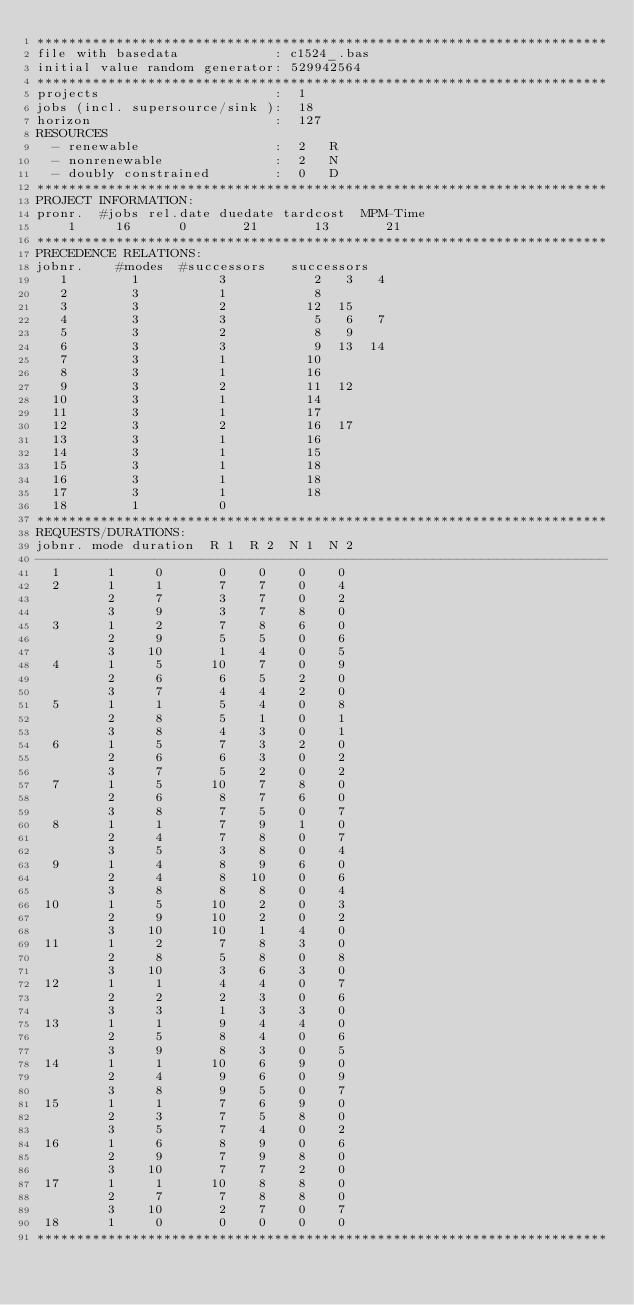<code> <loc_0><loc_0><loc_500><loc_500><_ObjectiveC_>************************************************************************
file with basedata            : c1524_.bas
initial value random generator: 529942564
************************************************************************
projects                      :  1
jobs (incl. supersource/sink ):  18
horizon                       :  127
RESOURCES
  - renewable                 :  2   R
  - nonrenewable              :  2   N
  - doubly constrained        :  0   D
************************************************************************
PROJECT INFORMATION:
pronr.  #jobs rel.date duedate tardcost  MPM-Time
    1     16      0       21       13       21
************************************************************************
PRECEDENCE RELATIONS:
jobnr.    #modes  #successors   successors
   1        1          3           2   3   4
   2        3          1           8
   3        3          2          12  15
   4        3          3           5   6   7
   5        3          2           8   9
   6        3          3           9  13  14
   7        3          1          10
   8        3          1          16
   9        3          2          11  12
  10        3          1          14
  11        3          1          17
  12        3          2          16  17
  13        3          1          16
  14        3          1          15
  15        3          1          18
  16        3          1          18
  17        3          1          18
  18        1          0        
************************************************************************
REQUESTS/DURATIONS:
jobnr. mode duration  R 1  R 2  N 1  N 2
------------------------------------------------------------------------
  1      1     0       0    0    0    0
  2      1     1       7    7    0    4
         2     7       3    7    0    2
         3     9       3    7    8    0
  3      1     2       7    8    6    0
         2     9       5    5    0    6
         3    10       1    4    0    5
  4      1     5      10    7    0    9
         2     6       6    5    2    0
         3     7       4    4    2    0
  5      1     1       5    4    0    8
         2     8       5    1    0    1
         3     8       4    3    0    1
  6      1     5       7    3    2    0
         2     6       6    3    0    2
         3     7       5    2    0    2
  7      1     5      10    7    8    0
         2     6       8    7    6    0
         3     8       7    5    0    7
  8      1     1       7    9    1    0
         2     4       7    8    0    7
         3     5       3    8    0    4
  9      1     4       8    9    6    0
         2     4       8   10    0    6
         3     8       8    8    0    4
 10      1     5      10    2    0    3
         2     9      10    2    0    2
         3    10      10    1    4    0
 11      1     2       7    8    3    0
         2     8       5    8    0    8
         3    10       3    6    3    0
 12      1     1       4    4    0    7
         2     2       2    3    0    6
         3     3       1    3    3    0
 13      1     1       9    4    4    0
         2     5       8    4    0    6
         3     9       8    3    0    5
 14      1     1      10    6    9    0
         2     4       9    6    0    9
         3     8       9    5    0    7
 15      1     1       7    6    9    0
         2     3       7    5    8    0
         3     5       7    4    0    2
 16      1     6       8    9    0    6
         2     9       7    9    8    0
         3    10       7    7    2    0
 17      1     1      10    8    8    0
         2     7       7    8    8    0
         3    10       2    7    0    7
 18      1     0       0    0    0    0
************************************************************************</code> 